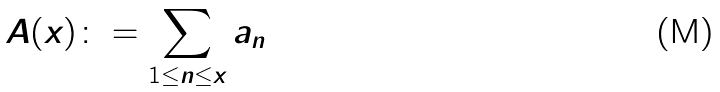<formula> <loc_0><loc_0><loc_500><loc_500>A ( x ) \colon = \sum _ { 1 \leq n \leq x } a _ { n }</formula> 